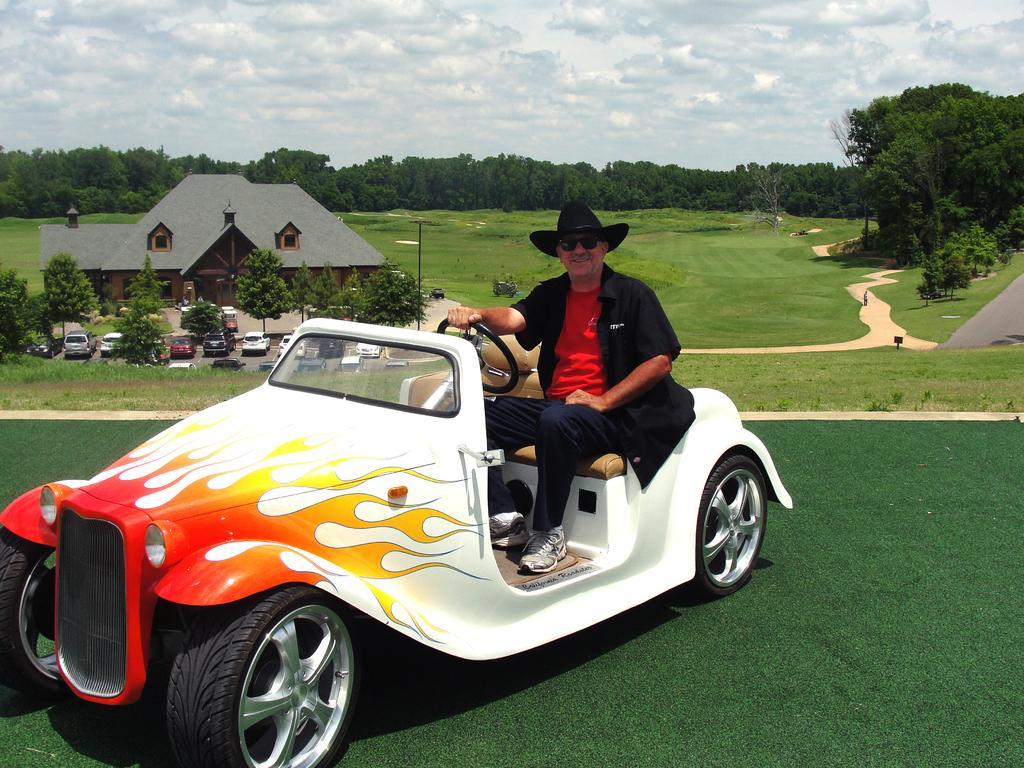How would you summarize this image in a sentence or two? A man in red and black dress is wearing spectacles and hat holding the steering and sitting on a vehicle. And there is a lawn. And in the background there is a house, trees and vehicles are parked. And the sky is looking very clear. And there is a road. 